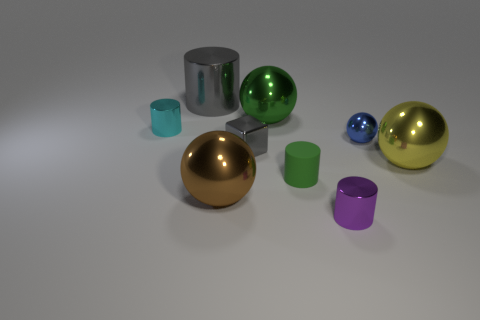How do the materials of the objects compare in terms of reflection and texture? The materials of the objects in the image exhibit varied reflection and texture characteristics. The spheres and cylinder have a high-gloss finish and reflect the environment, indicating a smooth, metallic surface. The cups, on the other hand, appear to have a matte finish with less reflection, suggesting a more diffuse surface texture, potentially resembling plastic or ceramic. 